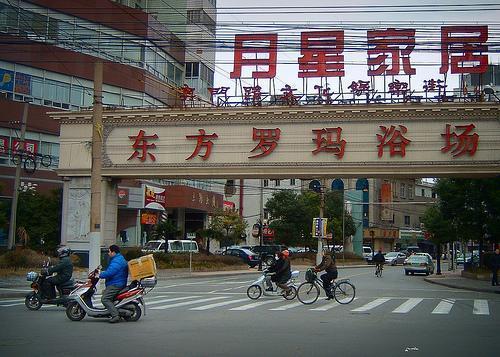How many people are wearing blue shirt?
Give a very brief answer. 1. 